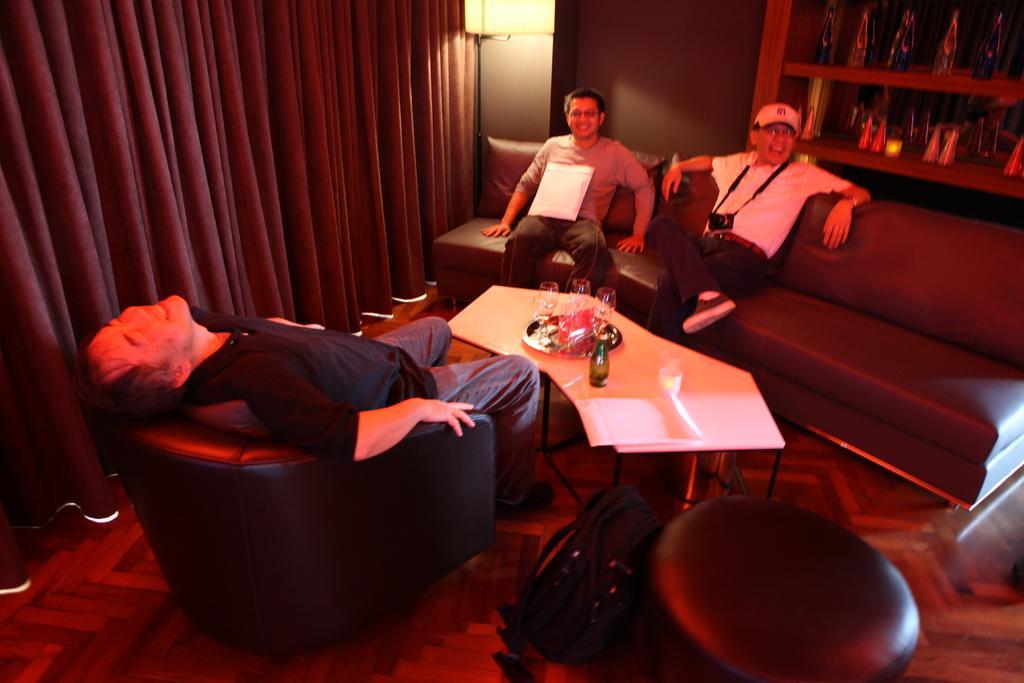Could you give a brief overview of what you see in this image? In this image I can see three men are sitting on the sofa and smiling. This is an inside view. On the top right side of the image there is a rack in which few objects are filled. On the left side there is a red color curtain. On the bottom of the image I can see a black color bag on the floor. In the middle of the room there is a table on which few glasses and a bottle is placed. 